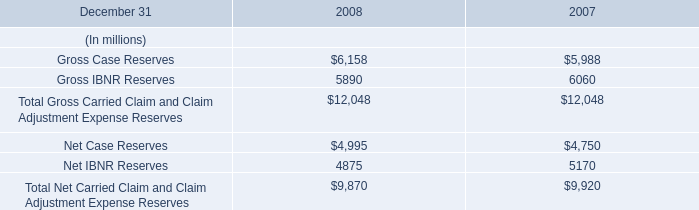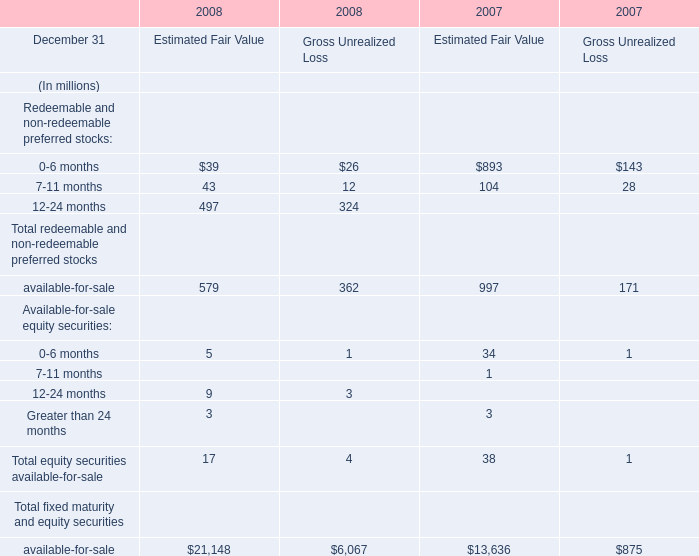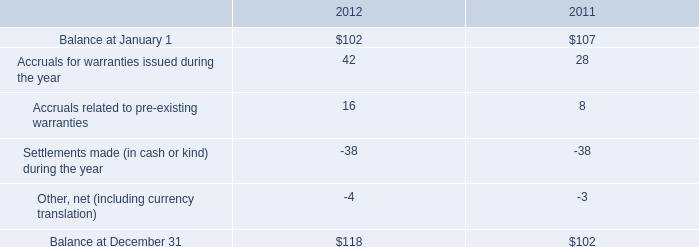what was the percent of the change in the company 2019s warranty liability from 2011 to 2012 
Computations: ((118 - 102) / 102)
Answer: 0.15686. 